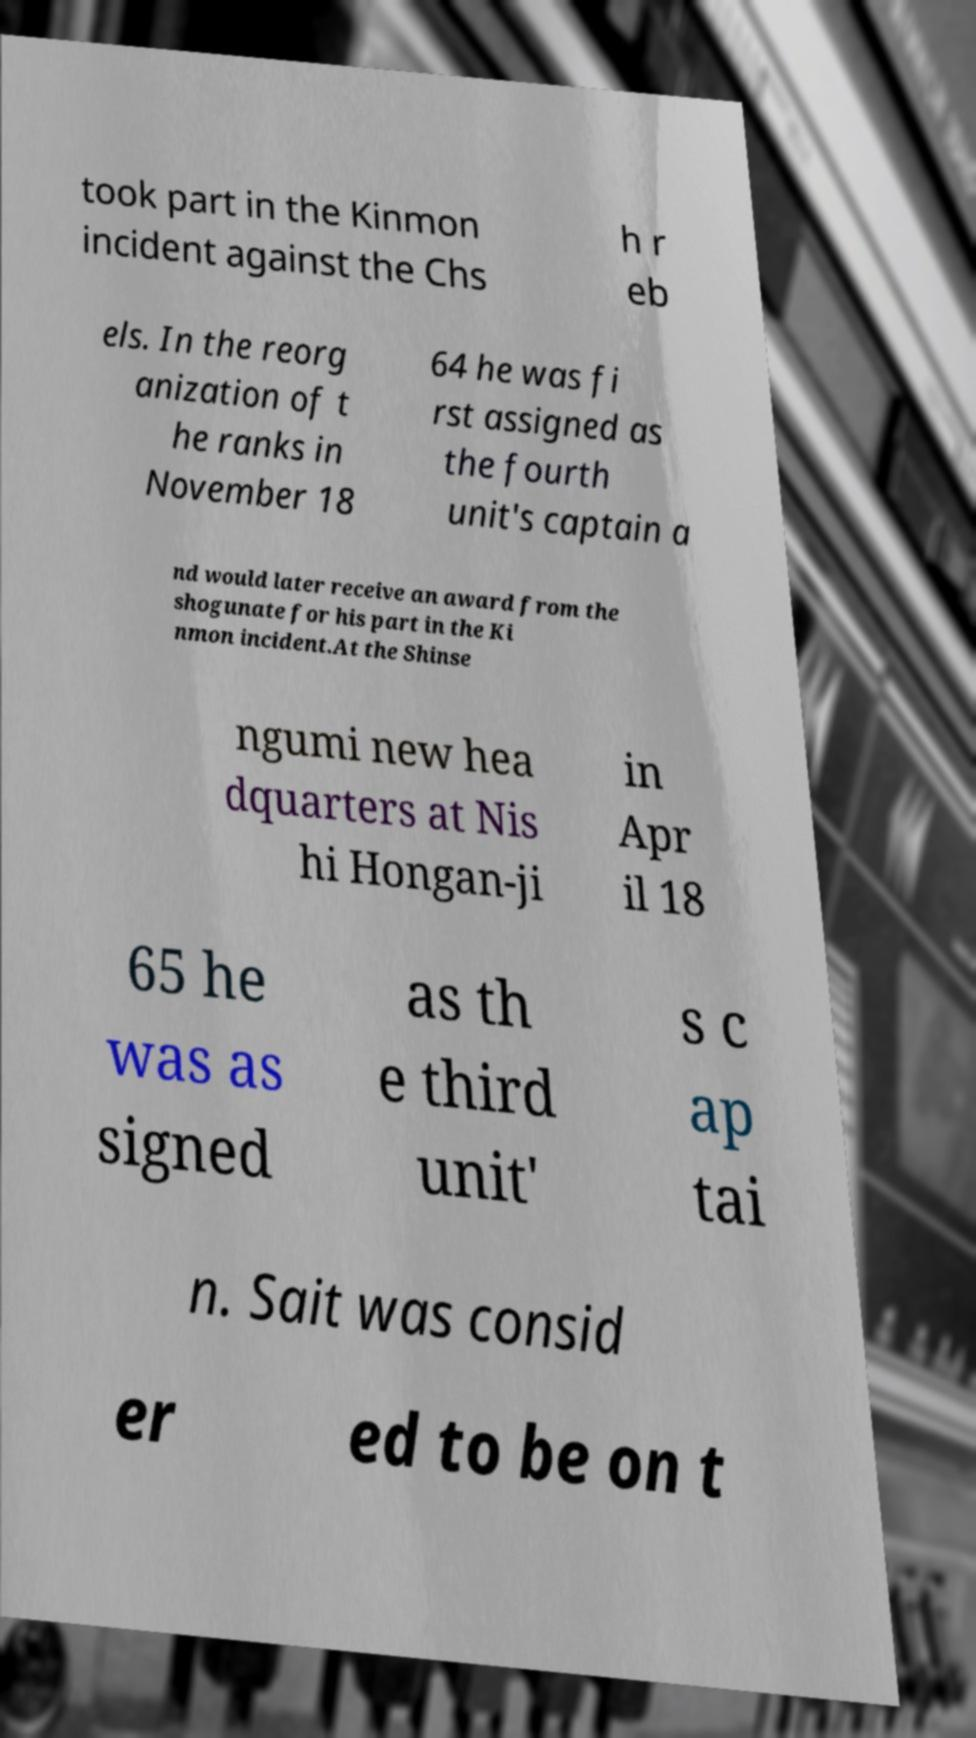Can you accurately transcribe the text from the provided image for me? took part in the Kinmon incident against the Chs h r eb els. In the reorg anization of t he ranks in November 18 64 he was fi rst assigned as the fourth unit's captain a nd would later receive an award from the shogunate for his part in the Ki nmon incident.At the Shinse ngumi new hea dquarters at Nis hi Hongan-ji in Apr il 18 65 he was as signed as th e third unit' s c ap tai n. Sait was consid er ed to be on t 